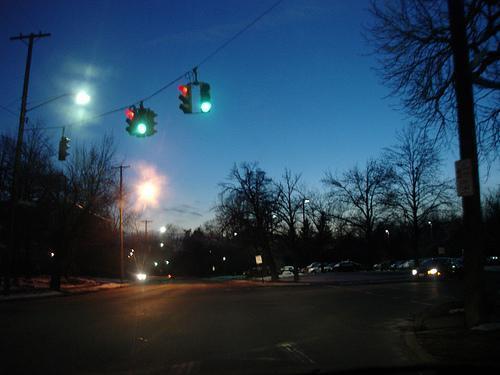How many green lights are in the picture?
Give a very brief answer. 2. 